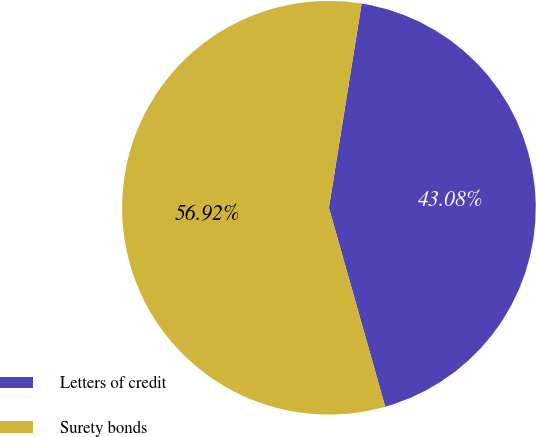<chart> <loc_0><loc_0><loc_500><loc_500><pie_chart><fcel>Letters of credit<fcel>Surety bonds<nl><fcel>43.08%<fcel>56.92%<nl></chart> 